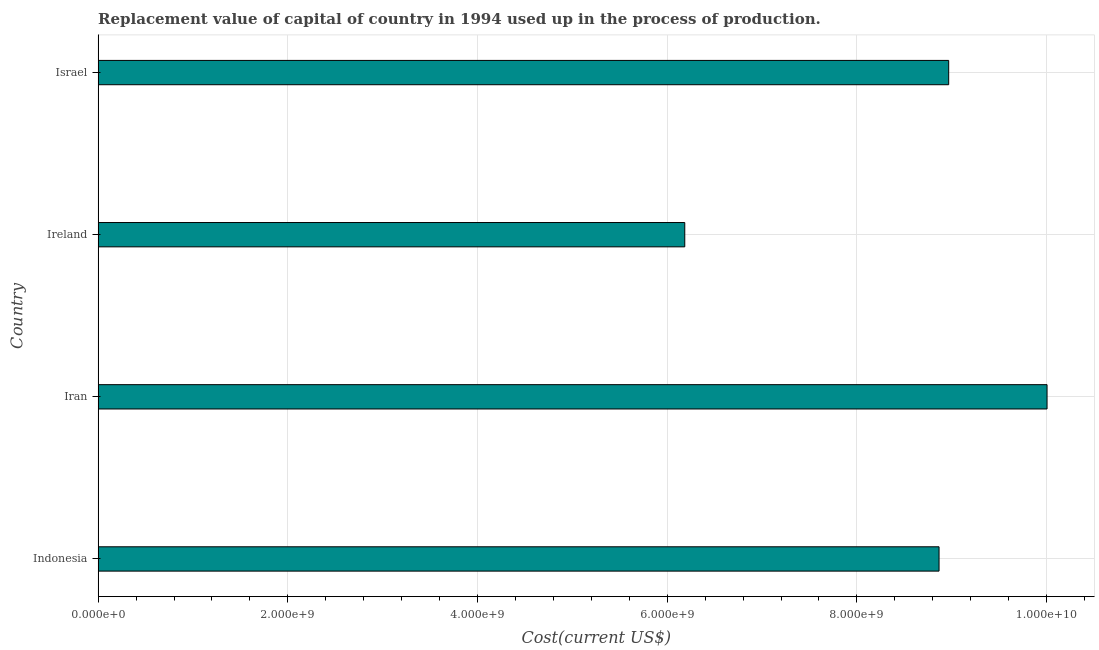Does the graph contain any zero values?
Make the answer very short. No. Does the graph contain grids?
Offer a very short reply. Yes. What is the title of the graph?
Keep it short and to the point. Replacement value of capital of country in 1994 used up in the process of production. What is the label or title of the X-axis?
Offer a terse response. Cost(current US$). What is the consumption of fixed capital in Indonesia?
Make the answer very short. 8.87e+09. Across all countries, what is the maximum consumption of fixed capital?
Your response must be concise. 1.00e+1. Across all countries, what is the minimum consumption of fixed capital?
Provide a short and direct response. 6.19e+09. In which country was the consumption of fixed capital maximum?
Keep it short and to the point. Iran. In which country was the consumption of fixed capital minimum?
Your answer should be very brief. Ireland. What is the sum of the consumption of fixed capital?
Your response must be concise. 3.40e+1. What is the difference between the consumption of fixed capital in Indonesia and Iran?
Provide a succinct answer. -1.14e+09. What is the average consumption of fixed capital per country?
Make the answer very short. 8.51e+09. What is the median consumption of fixed capital?
Offer a terse response. 8.92e+09. What is the ratio of the consumption of fixed capital in Iran to that in Israel?
Your response must be concise. 1.12. Is the consumption of fixed capital in Indonesia less than that in Israel?
Give a very brief answer. Yes. What is the difference between the highest and the second highest consumption of fixed capital?
Ensure brevity in your answer.  1.04e+09. What is the difference between the highest and the lowest consumption of fixed capital?
Keep it short and to the point. 3.82e+09. Are all the bars in the graph horizontal?
Provide a short and direct response. Yes. What is the Cost(current US$) in Indonesia?
Provide a succinct answer. 8.87e+09. What is the Cost(current US$) of Iran?
Offer a very short reply. 1.00e+1. What is the Cost(current US$) in Ireland?
Keep it short and to the point. 6.19e+09. What is the Cost(current US$) of Israel?
Make the answer very short. 8.97e+09. What is the difference between the Cost(current US$) in Indonesia and Iran?
Your response must be concise. -1.14e+09. What is the difference between the Cost(current US$) in Indonesia and Ireland?
Your answer should be compact. 2.68e+09. What is the difference between the Cost(current US$) in Indonesia and Israel?
Make the answer very short. -1.02e+08. What is the difference between the Cost(current US$) in Iran and Ireland?
Keep it short and to the point. 3.82e+09. What is the difference between the Cost(current US$) in Iran and Israel?
Make the answer very short. 1.04e+09. What is the difference between the Cost(current US$) in Ireland and Israel?
Your response must be concise. -2.78e+09. What is the ratio of the Cost(current US$) in Indonesia to that in Iran?
Your answer should be compact. 0.89. What is the ratio of the Cost(current US$) in Indonesia to that in Ireland?
Provide a short and direct response. 1.43. What is the ratio of the Cost(current US$) in Indonesia to that in Israel?
Offer a terse response. 0.99. What is the ratio of the Cost(current US$) in Iran to that in Ireland?
Give a very brief answer. 1.62. What is the ratio of the Cost(current US$) in Iran to that in Israel?
Give a very brief answer. 1.12. What is the ratio of the Cost(current US$) in Ireland to that in Israel?
Keep it short and to the point. 0.69. 